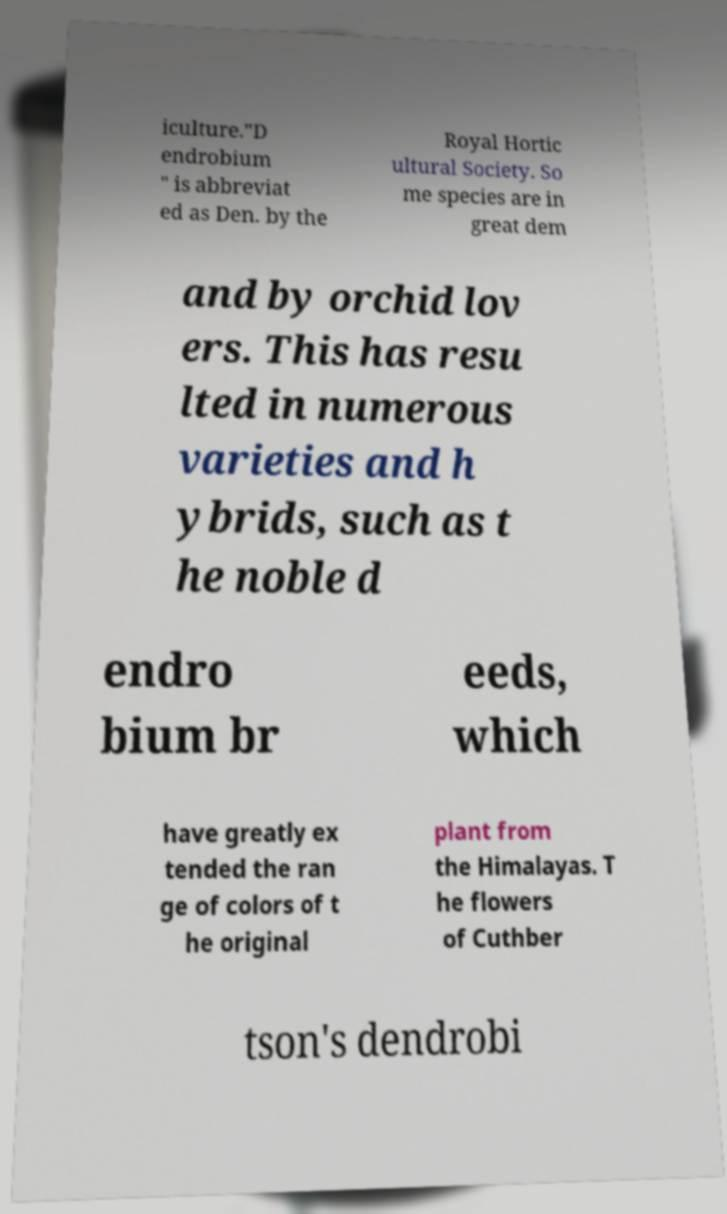Could you assist in decoding the text presented in this image and type it out clearly? iculture."D endrobium " is abbreviat ed as Den. by the Royal Hortic ultural Society. So me species are in great dem and by orchid lov ers. This has resu lted in numerous varieties and h ybrids, such as t he noble d endro bium br eeds, which have greatly ex tended the ran ge of colors of t he original plant from the Himalayas. T he flowers of Cuthber tson's dendrobi 